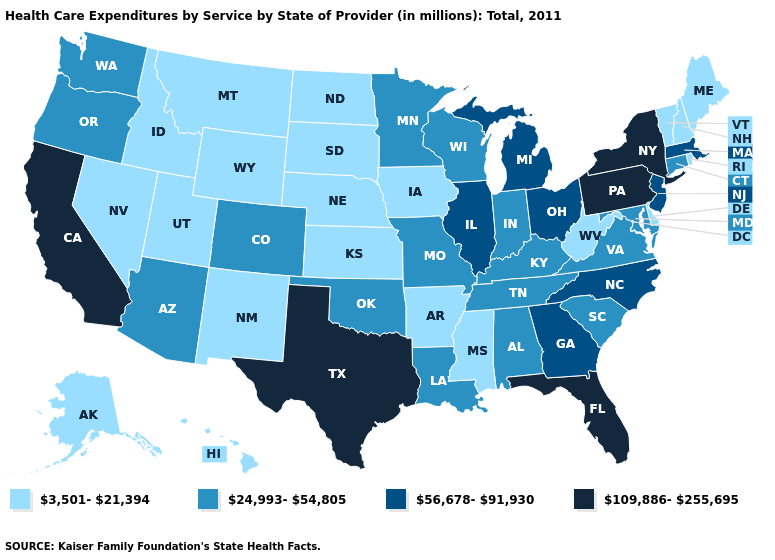Among the states that border Delaware , does Pennsylvania have the highest value?
Quick response, please. Yes. Name the states that have a value in the range 56,678-91,930?
Short answer required. Georgia, Illinois, Massachusetts, Michigan, New Jersey, North Carolina, Ohio. Name the states that have a value in the range 24,993-54,805?
Give a very brief answer. Alabama, Arizona, Colorado, Connecticut, Indiana, Kentucky, Louisiana, Maryland, Minnesota, Missouri, Oklahoma, Oregon, South Carolina, Tennessee, Virginia, Washington, Wisconsin. Among the states that border Alabama , which have the highest value?
Be succinct. Florida. Among the states that border Kentucky , does Ohio have the highest value?
Quick response, please. Yes. Name the states that have a value in the range 24,993-54,805?
Write a very short answer. Alabama, Arizona, Colorado, Connecticut, Indiana, Kentucky, Louisiana, Maryland, Minnesota, Missouri, Oklahoma, Oregon, South Carolina, Tennessee, Virginia, Washington, Wisconsin. Among the states that border Florida , which have the highest value?
Be succinct. Georgia. Name the states that have a value in the range 109,886-255,695?
Give a very brief answer. California, Florida, New York, Pennsylvania, Texas. What is the highest value in the USA?
Short answer required. 109,886-255,695. Name the states that have a value in the range 109,886-255,695?
Be succinct. California, Florida, New York, Pennsylvania, Texas. Which states hav the highest value in the MidWest?
Keep it brief. Illinois, Michigan, Ohio. Does Pennsylvania have a higher value than New York?
Give a very brief answer. No. What is the value of Georgia?
Quick response, please. 56,678-91,930. What is the highest value in states that border California?
Keep it brief. 24,993-54,805. Does Minnesota have the lowest value in the USA?
Be succinct. No. 